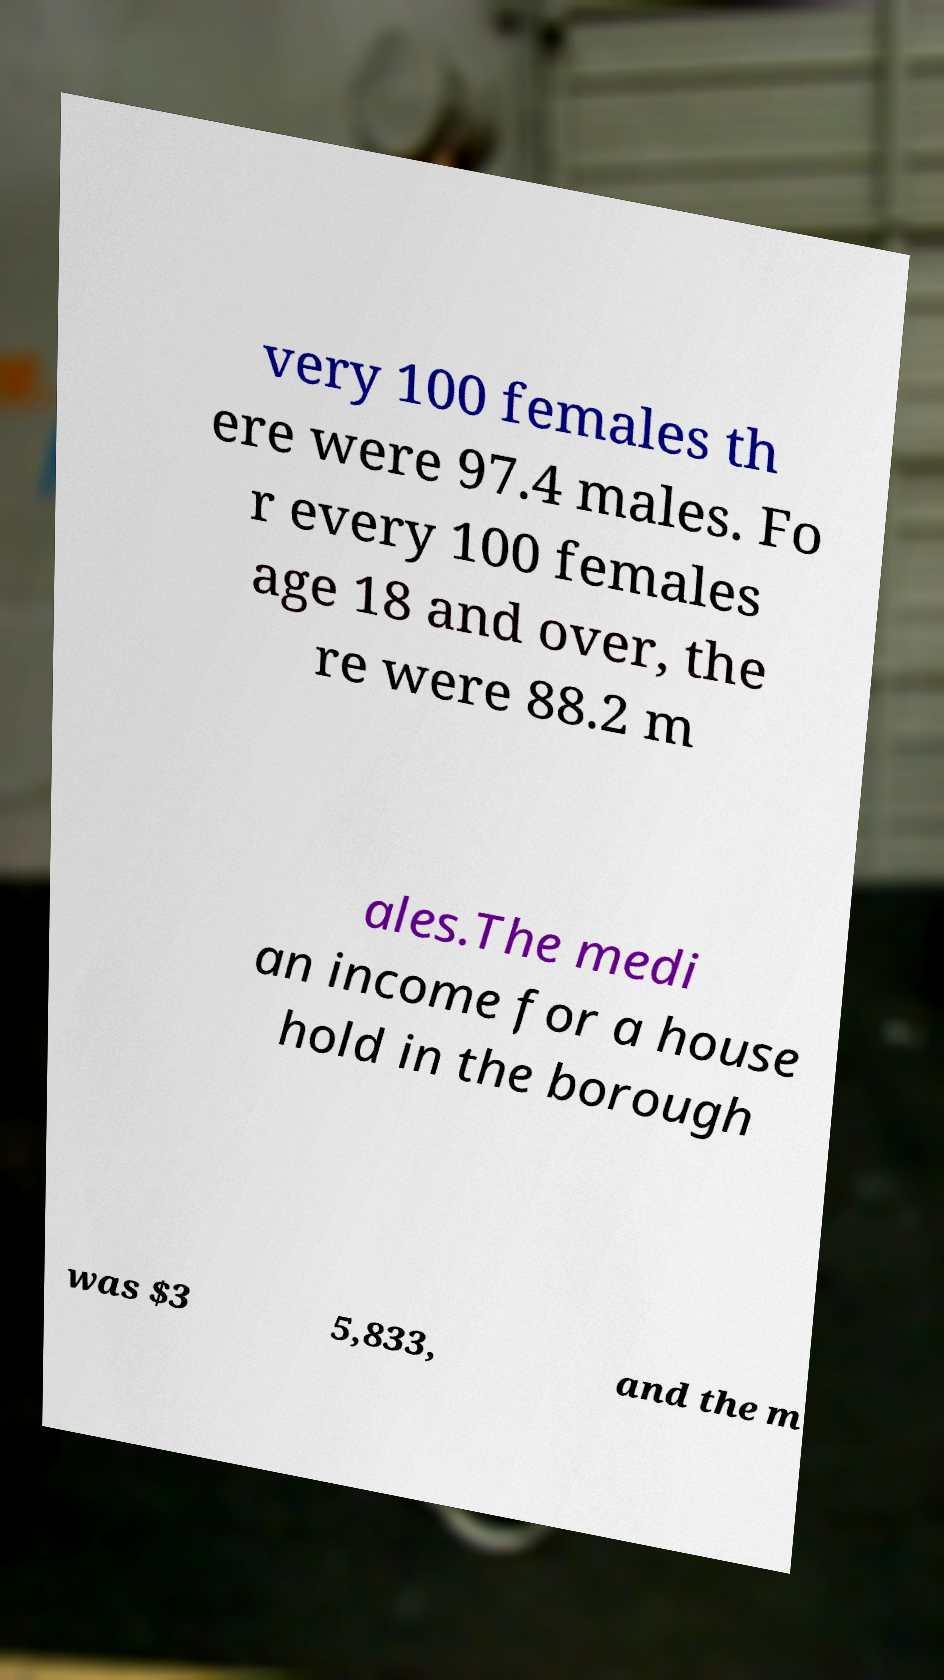What messages or text are displayed in this image? I need them in a readable, typed format. very 100 females th ere were 97.4 males. Fo r every 100 females age 18 and over, the re were 88.2 m ales.The medi an income for a house hold in the borough was $3 5,833, and the m 